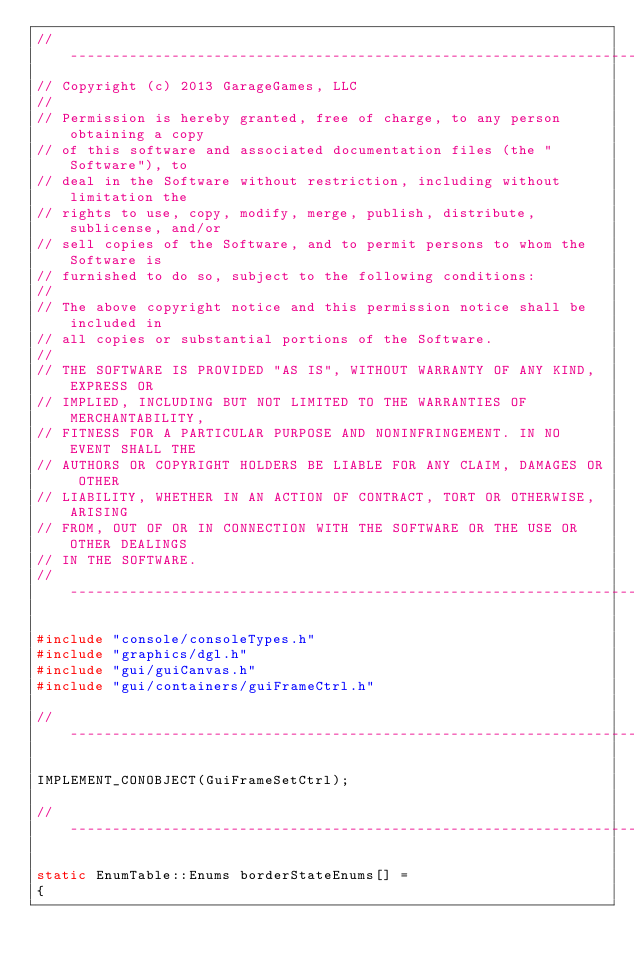<code> <loc_0><loc_0><loc_500><loc_500><_C++_>//-----------------------------------------------------------------------------
// Copyright (c) 2013 GarageGames, LLC
//
// Permission is hereby granted, free of charge, to any person obtaining a copy
// of this software and associated documentation files (the "Software"), to
// deal in the Software without restriction, including without limitation the
// rights to use, copy, modify, merge, publish, distribute, sublicense, and/or
// sell copies of the Software, and to permit persons to whom the Software is
// furnished to do so, subject to the following conditions:
//
// The above copyright notice and this permission notice shall be included in
// all copies or substantial portions of the Software.
//
// THE SOFTWARE IS PROVIDED "AS IS", WITHOUT WARRANTY OF ANY KIND, EXPRESS OR
// IMPLIED, INCLUDING BUT NOT LIMITED TO THE WARRANTIES OF MERCHANTABILITY,
// FITNESS FOR A PARTICULAR PURPOSE AND NONINFRINGEMENT. IN NO EVENT SHALL THE
// AUTHORS OR COPYRIGHT HOLDERS BE LIABLE FOR ANY CLAIM, DAMAGES OR OTHER
// LIABILITY, WHETHER IN AN ACTION OF CONTRACT, TORT OR OTHERWISE, ARISING
// FROM, OUT OF OR IN CONNECTION WITH THE SOFTWARE OR THE USE OR OTHER DEALINGS
// IN THE SOFTWARE.
//-----------------------------------------------------------------------------

#include "console/consoleTypes.h"
#include "graphics/dgl.h"
#include "gui/guiCanvas.h"
#include "gui/containers/guiFrameCtrl.h"

//-----------------------------------------------------------------------------

IMPLEMENT_CONOBJECT(GuiFrameSetCtrl);

//-----------------------------------------------------------------------------

static EnumTable::Enums borderStateEnums[] =
{</code> 